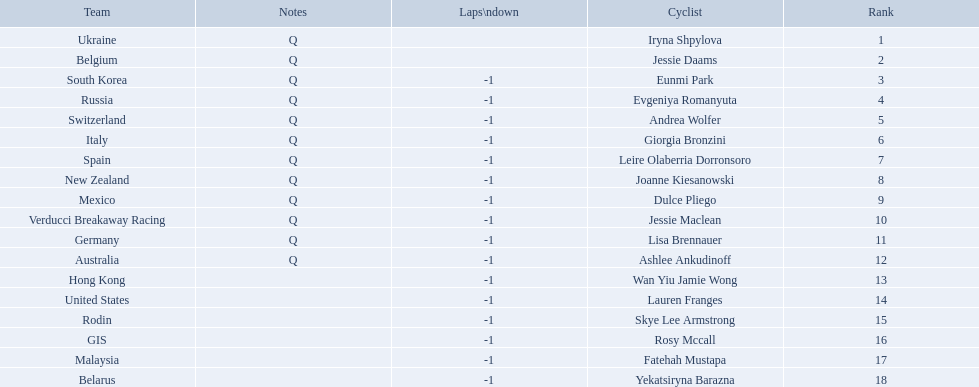Who competed in the race? Iryna Shpylova, Jessie Daams, Eunmi Park, Evgeniya Romanyuta, Andrea Wolfer, Giorgia Bronzini, Leire Olaberria Dorronsoro, Joanne Kiesanowski, Dulce Pliego, Jessie Maclean, Lisa Brennauer, Ashlee Ankudinoff, Wan Yiu Jamie Wong, Lauren Franges, Skye Lee Armstrong, Rosy Mccall, Fatehah Mustapa, Yekatsiryna Barazna. Who ranked highest in the race? Iryna Shpylova. 